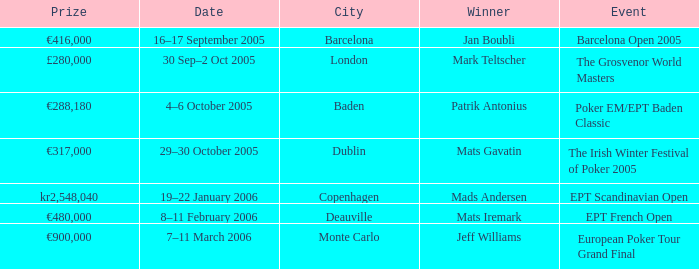Would you mind parsing the complete table? {'header': ['Prize', 'Date', 'City', 'Winner', 'Event'], 'rows': [['€416,000', '16–17 September 2005', 'Barcelona', 'Jan Boubli', 'Barcelona Open 2005'], ['£280,000', '30 Sep–2 Oct 2005', 'London', 'Mark Teltscher', 'The Grosvenor World Masters'], ['€288,180', '4–6 October 2005', 'Baden', 'Patrik Antonius', 'Poker EM/EPT Baden Classic'], ['€317,000', '29–30 October 2005', 'Dublin', 'Mats Gavatin', 'The Irish Winter Festival of Poker 2005'], ['kr2,548,040', '19–22 January 2006', 'Copenhagen', 'Mads Andersen', 'EPT Scandinavian Open'], ['€480,000', '8–11 February 2006', 'Deauville', 'Mats Iremark', 'EPT French Open'], ['€900,000', '7–11 March 2006', 'Monte Carlo', 'Jeff Williams', 'European Poker Tour Grand Final']]} What event had a prize of €900,000? European Poker Tour Grand Final. 